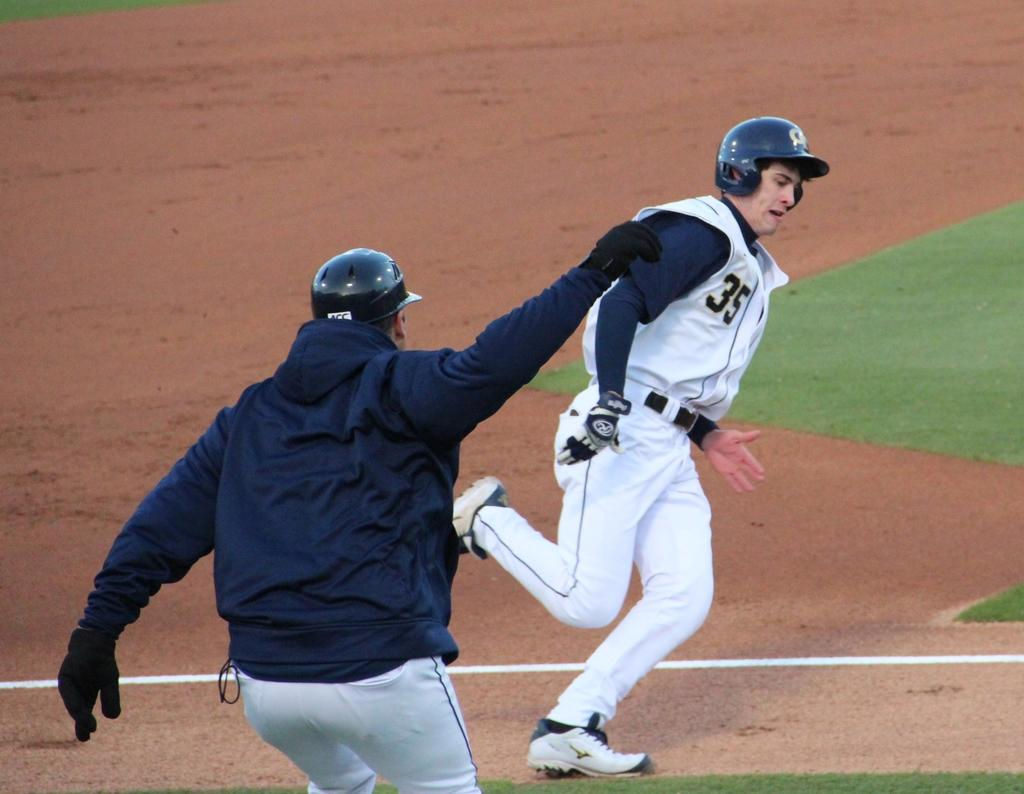How many people are present in the image? There are two people in the image. What are the people doing in the image? The people are playing in a ground. What protective gear are the people wearing? The people are wearing helmets and gloves. What type of pan can be seen being used by the people in the image? There is no pan present in the image; the people are playing and wearing protective gear. 